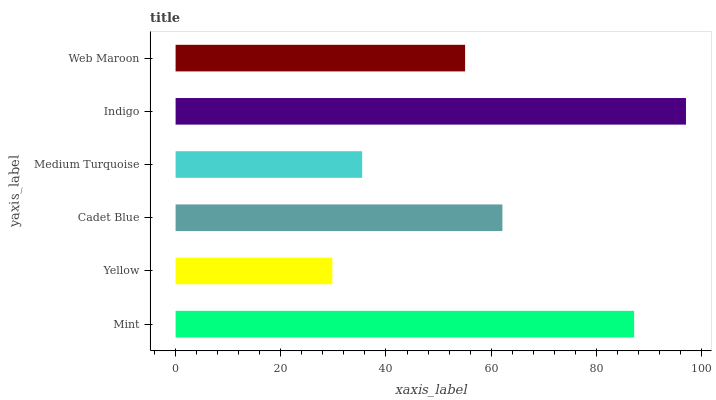Is Yellow the minimum?
Answer yes or no. Yes. Is Indigo the maximum?
Answer yes or no. Yes. Is Cadet Blue the minimum?
Answer yes or no. No. Is Cadet Blue the maximum?
Answer yes or no. No. Is Cadet Blue greater than Yellow?
Answer yes or no. Yes. Is Yellow less than Cadet Blue?
Answer yes or no. Yes. Is Yellow greater than Cadet Blue?
Answer yes or no. No. Is Cadet Blue less than Yellow?
Answer yes or no. No. Is Cadet Blue the high median?
Answer yes or no. Yes. Is Web Maroon the low median?
Answer yes or no. Yes. Is Medium Turquoise the high median?
Answer yes or no. No. Is Mint the low median?
Answer yes or no. No. 